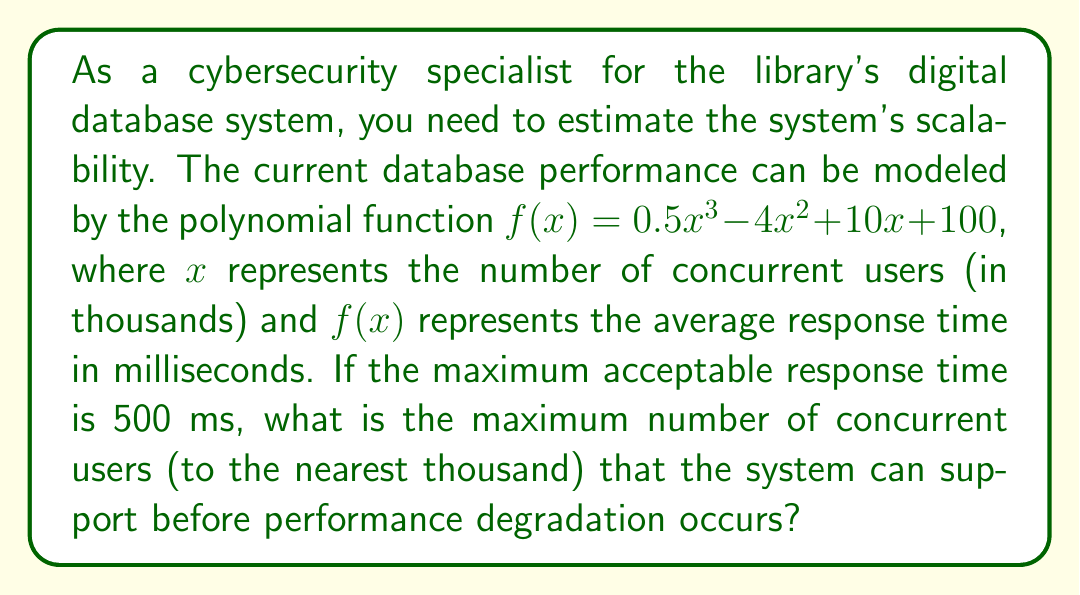Provide a solution to this math problem. To solve this problem, we need to find the value of $x$ where $f(x) = 500$. This involves the following steps:

1) Set up the equation:
   $500 = 0.5x^3 - 4x^2 + 10x + 100$

2) Rearrange the equation to standard form:
   $0.5x^3 - 4x^2 + 10x - 400 = 0$

3) This cubic equation doesn't have an obvious rational solution, so we'll use a graphical method to approximate the solution.

4) We can plot the function $g(x) = 0.5x^3 - 4x^2 + 10x - 400$ and find where it crosses the x-axis.

[asy]
import graph;
size(200,200);

real f(real x) {return 0.5x^3 - 4x^2 + 10x - 400;}

xaxis("x",Arrow);
yaxis("y",Arrow);

draw(graph(f,-1,12));

dot((8.76,0));
label("(8.76,0)",(8.76,0),NE);
[/asy]

5) From the graph, we can see that the function crosses the x-axis at approximately $x = 8.76$.

6) This means that when there are about 8,760 concurrent users, the response time will reach 500 ms.

7) Rounding to the nearest thousand as requested in the question, we get 9,000 users.

To verify, we can plug this value back into the original function:

$f(9) = 0.5(9^3) - 4(9^2) + 10(9) + 100$
$    = 0.5(729) - 4(81) + 90 + 100$
$    = 364.5 - 324 + 90 + 100$
$    = 230.5$ ms

This is indeed less than 500 ms, confirming that 9,000 users is the correct answer.
Answer: The maximum number of concurrent users the system can support before performance degradation occurs is approximately 9,000 (to the nearest thousand). 